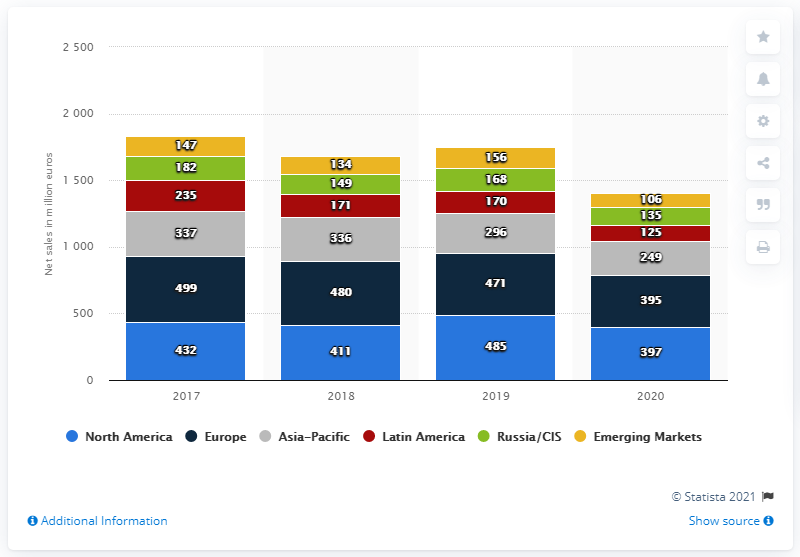Outline some significant characteristics in this image. In 2020, the net sales of the Reebok brand in North America were 397 million dollars. 